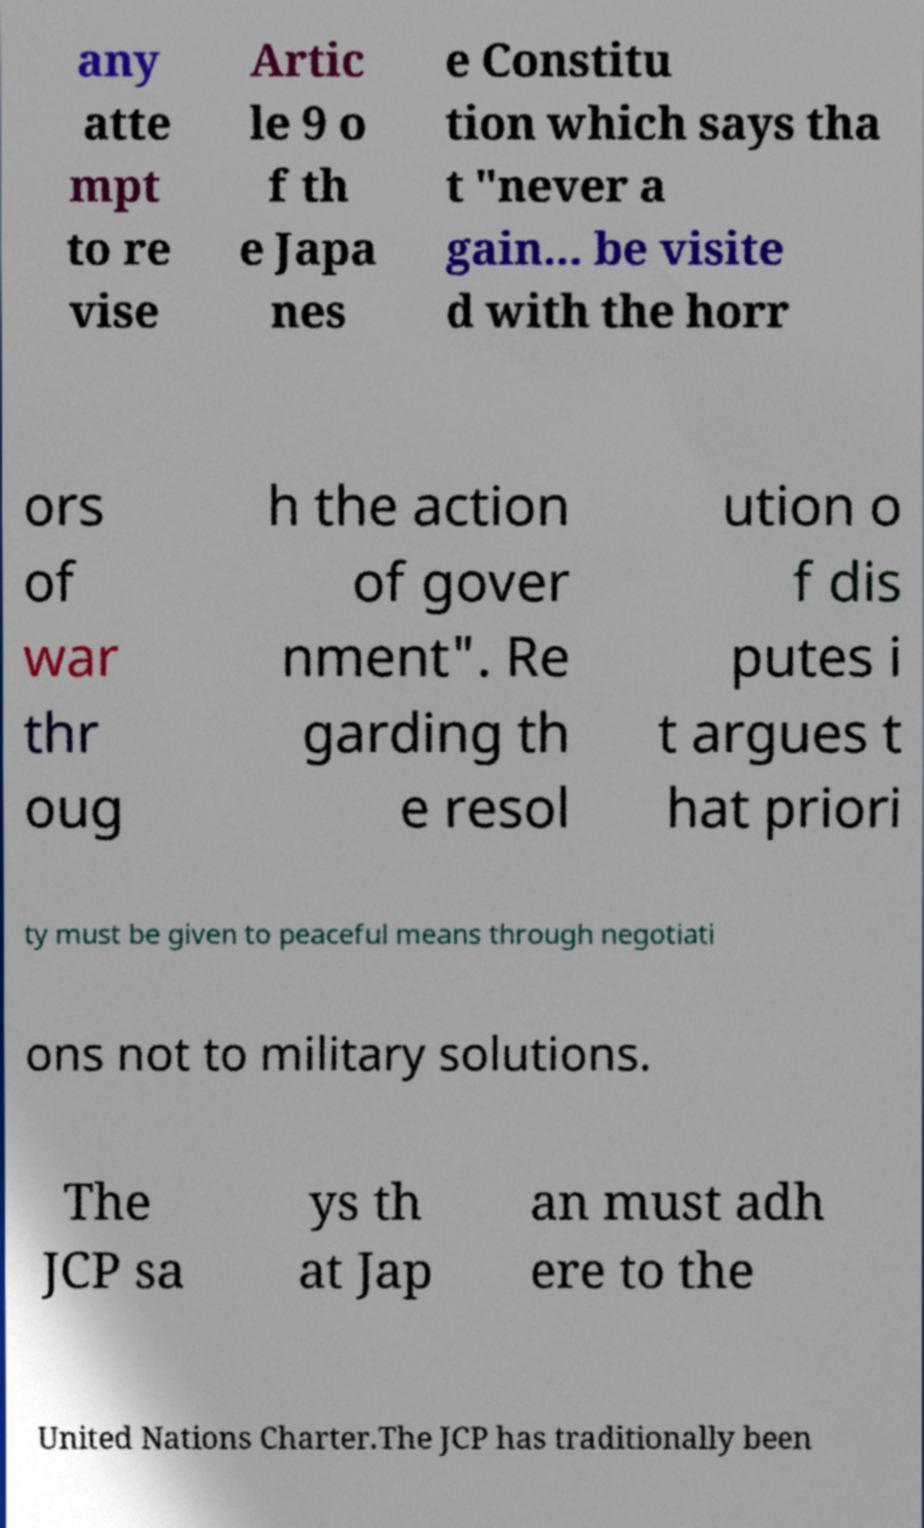Can you accurately transcribe the text from the provided image for me? any atte mpt to re vise Artic le 9 o f th e Japa nes e Constitu tion which says tha t "never a gain... be visite d with the horr ors of war thr oug h the action of gover nment". Re garding th e resol ution o f dis putes i t argues t hat priori ty must be given to peaceful means through negotiati ons not to military solutions. The JCP sa ys th at Jap an must adh ere to the United Nations Charter.The JCP has traditionally been 